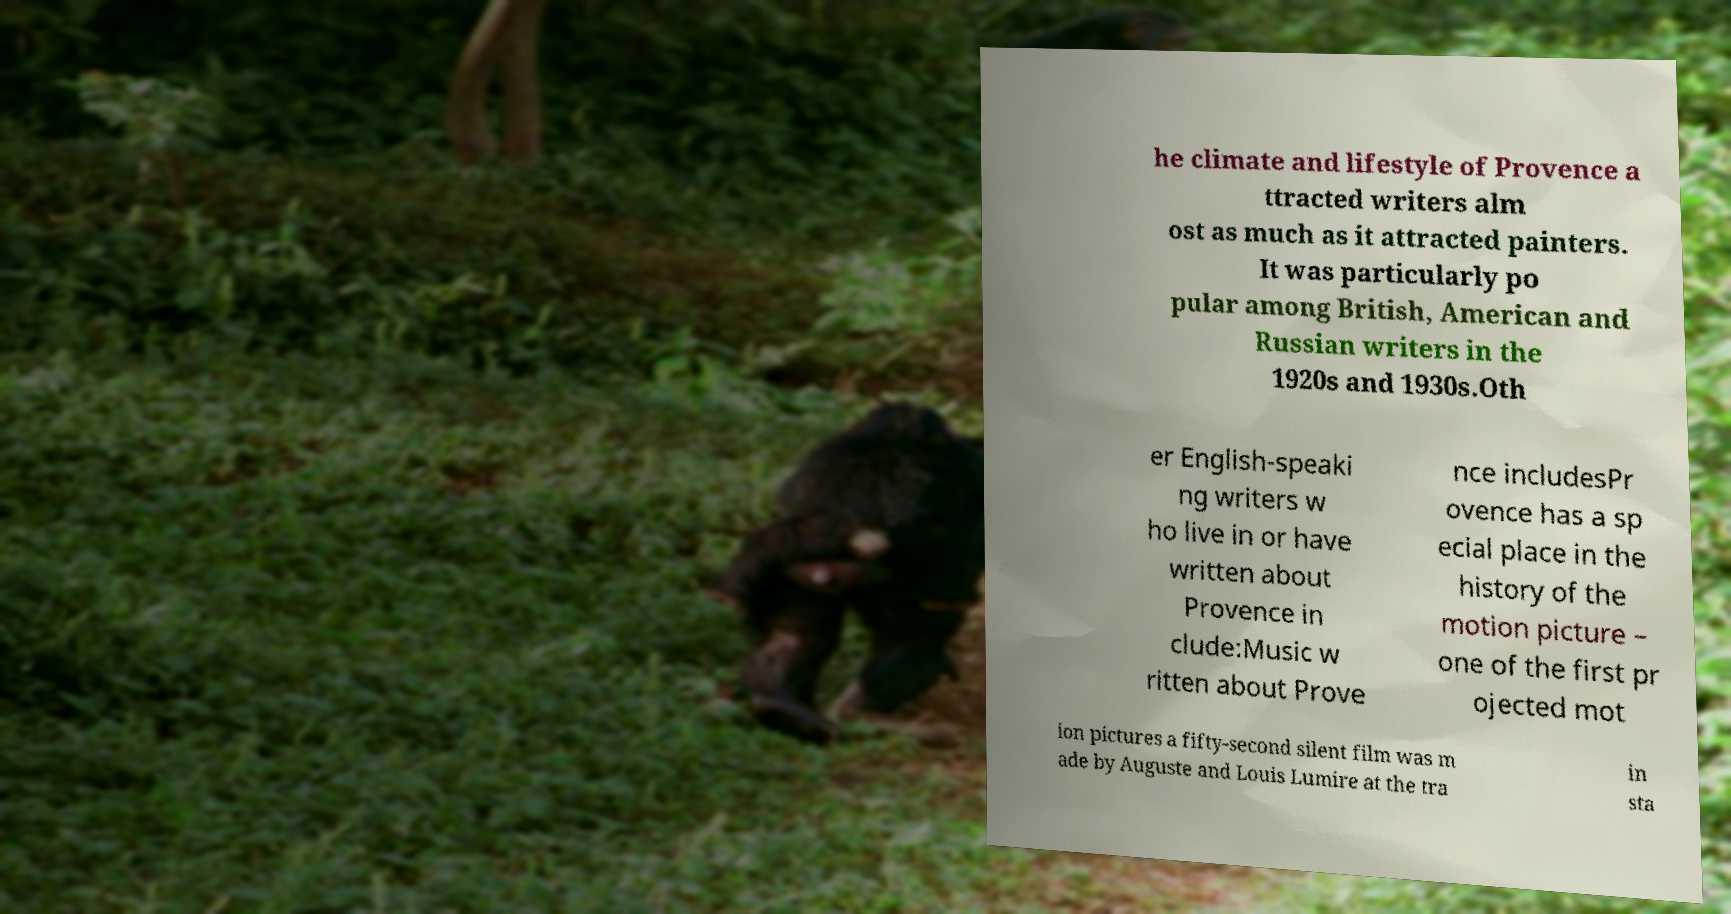I need the written content from this picture converted into text. Can you do that? he climate and lifestyle of Provence a ttracted writers alm ost as much as it attracted painters. It was particularly po pular among British, American and Russian writers in the 1920s and 1930s.Oth er English-speaki ng writers w ho live in or have written about Provence in clude:Music w ritten about Prove nce includesPr ovence has a sp ecial place in the history of the motion picture – one of the first pr ojected mot ion pictures a fifty-second silent film was m ade by Auguste and Louis Lumire at the tra in sta 